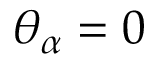Convert formula to latex. <formula><loc_0><loc_0><loc_500><loc_500>\theta _ { \alpha } = 0</formula> 